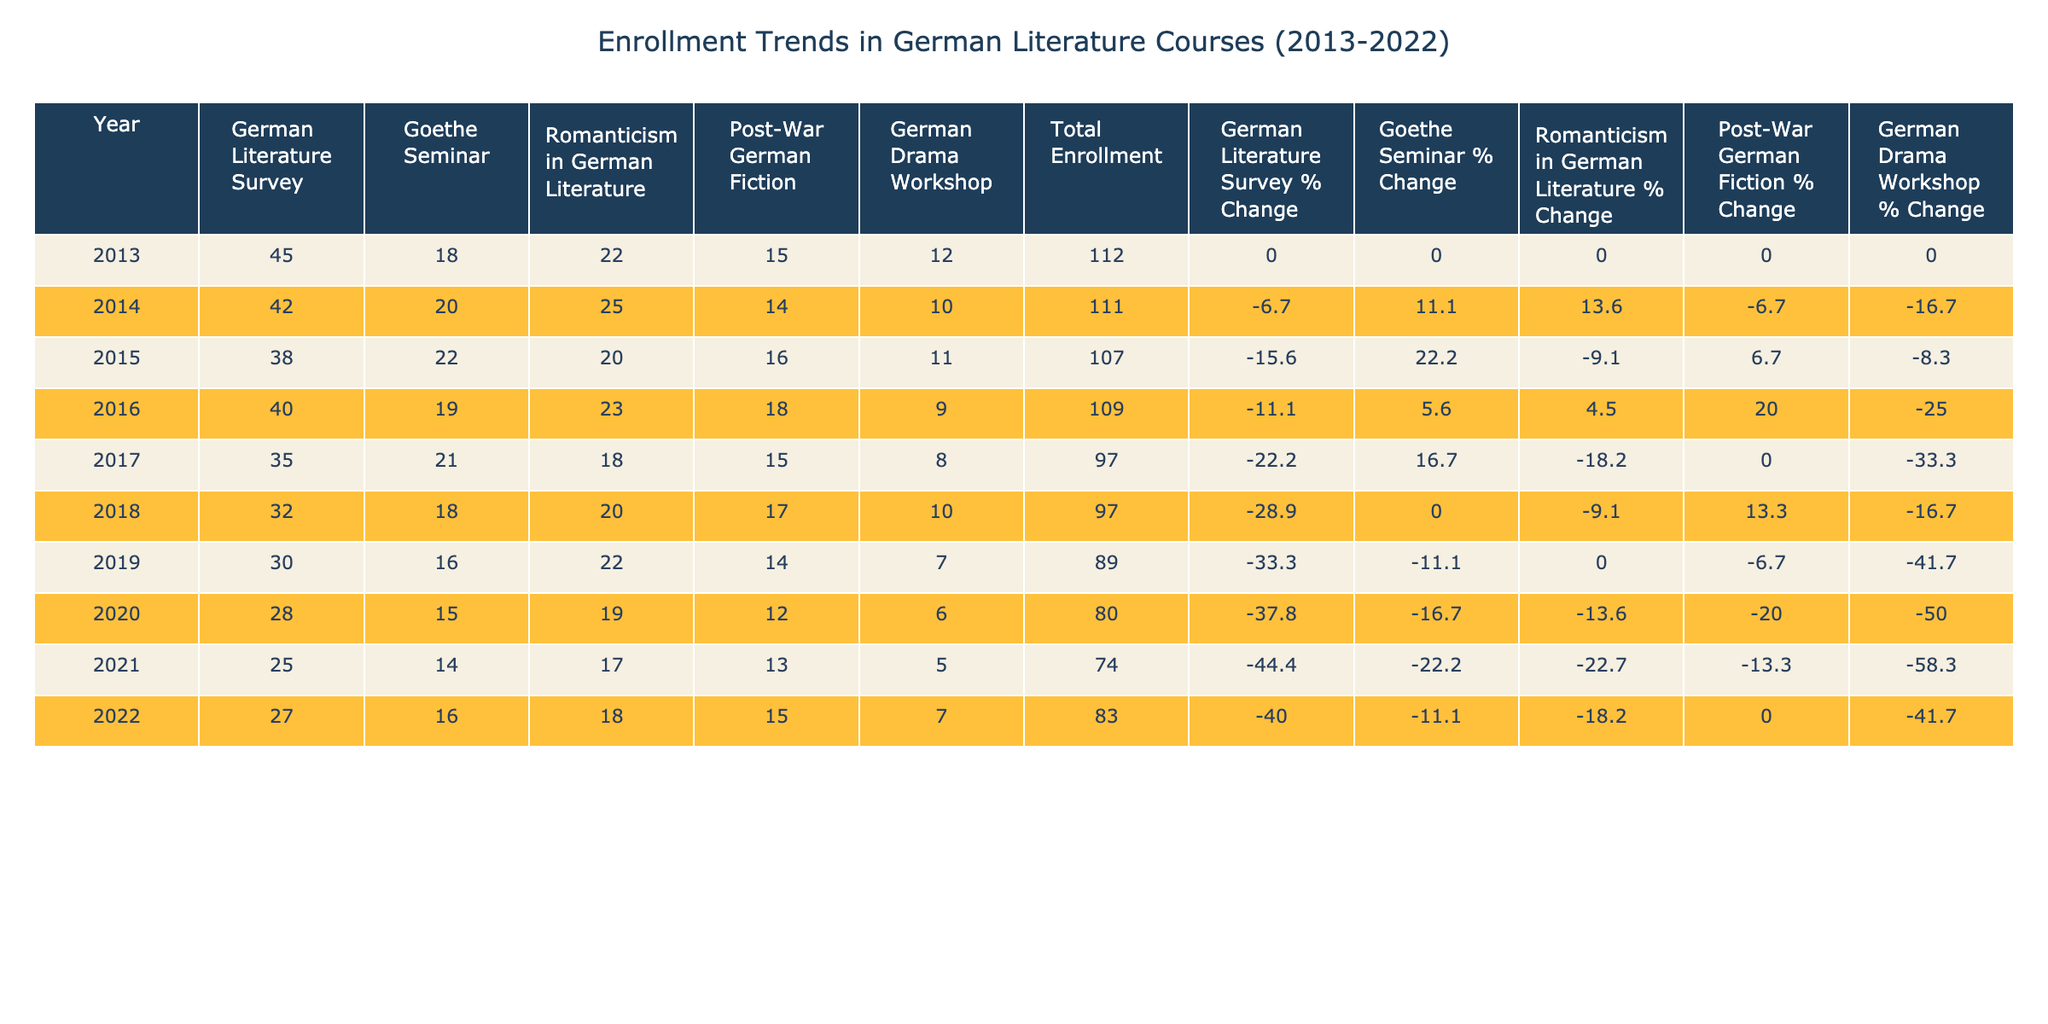What was the total enrollment in 2015? Looking at the 'Total Enrollment' column for the year 2015, the value is 107.
Answer: 107 Which course had the highest enrollment in 2018? In 2018, the highest enrollment among the courses occurs in the 'German Literature Survey' with a value of 32.
Answer: German Literature Survey What is the percentage change in enrollment for 'Post-War German Fiction' from 2013 to 2022? In 2013, the enrollment in 'Post-War German Fiction' was 15, and in 2022 it was 15. The percentage change is calculated as ((15 - 15) / 15) * 100 = 0%.
Answer: 0% How many total enrollments were there in the years 2014 to 2016? The total enrollments for 2014, 2015, and 2016 are 111, 107, and 109 respectively, so the sum is 111 + 107 + 109 = 327.
Answer: 327 Did the enrollment in 'German Drama Workshop' decrease every year from 2013 to 2022? Checking the values in the 'German Drama Workshop' column, they are 12 in 2013, 10 in 2014, 11 in 2015, 9 in 2016, 8 in 2017, 10 in 2018, 7 in 2019, 6 in 2020, 5 in 2021, and 7 in 2022. Since there is an increase from 2018 to 2019 (from 10 to 7) and then a slight increase again in 2022 (from 5 to 7), the enrollment did not decrease every year.
Answer: No What was the average enrollment across all courses in 2020? For the year 2020, the enrollment numbers are 28, 15, 19, 12, and 6. The average is calculated as (28 + 15 + 19 + 12 + 6) / 5 = 80 / 5 = 16.
Answer: 16 Which year had the lowest total enrollment? The total enrollment values for each year show that the lowest enrollment occurred in 2021 at 74.
Answer: 2021 What is the average enrollment in the 'Goethe Seminar' across all years? Adding the enrollments in the 'Goethe Seminar' column (18 + 20 + 22 + 19 + 21 + 18 + 16 + 15 + 14 + 16 =  195) and dividing by the number of years (10), the average is 195 / 10 = 19.5.
Answer: 19.5 Did the enrollment in 'Romanticism in German Literature' fluctuate between 2013 and 2022? Examining the values in the 'Romanticism in German Literature' column, they are 22, 25, 20, 23, 18, 20, 22, 19, 17, and 18. Since there are multiple increases and decreases, the enrollment did indeed fluctuate.
Answer: Yes 